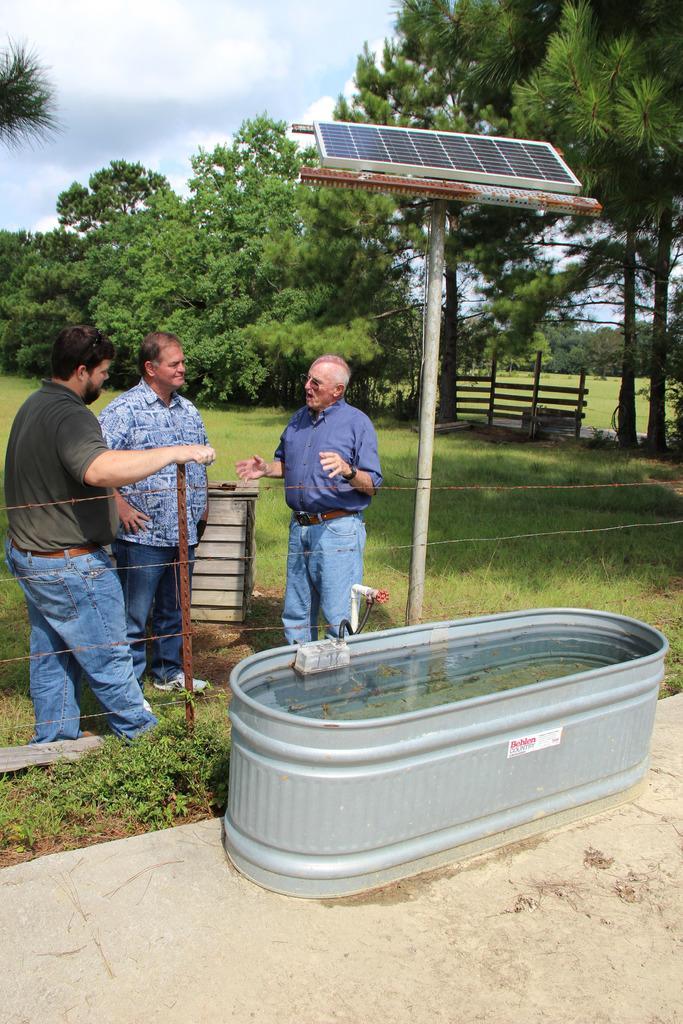In one or two sentences, can you explain what this image depicts? In the picture I can see three men standing on the green grass and the man on the right side is speaking. It is looking like a tub on the floor. I can see the metal fence and the solar panel board pole. In the background, I can see the trees and wooden fence. 